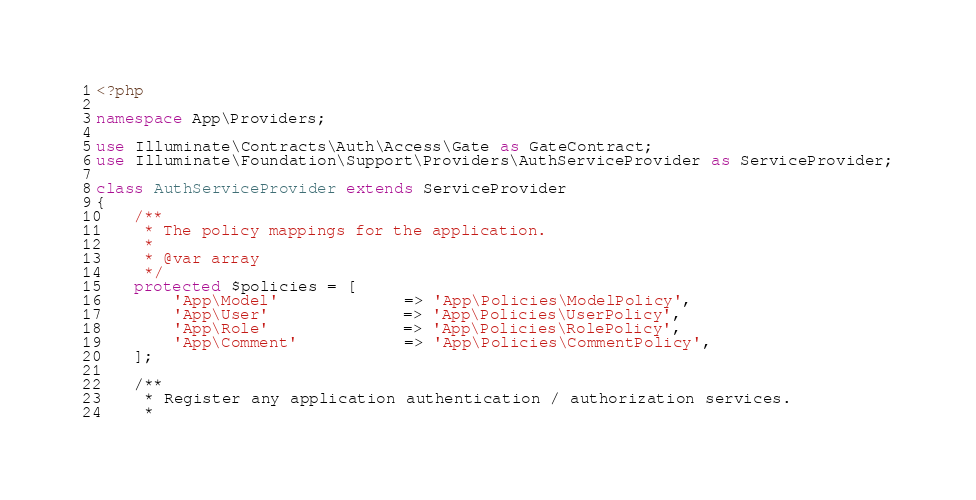Convert code to text. <code><loc_0><loc_0><loc_500><loc_500><_PHP_><?php

namespace App\Providers;

use Illuminate\Contracts\Auth\Access\Gate as GateContract;
use Illuminate\Foundation\Support\Providers\AuthServiceProvider as ServiceProvider;

class AuthServiceProvider extends ServiceProvider
{
    /**
     * The policy mappings for the application.
     *
     * @var array
     */
    protected $policies = [
        'App\Model'             => 'App\Policies\ModelPolicy',
        'App\User'              => 'App\Policies\UserPolicy',
        'App\Role'              => 'App\Policies\RolePolicy',
        'App\Comment'           => 'App\Policies\CommentPolicy',
    ];

    /**
     * Register any application authentication / authorization services.
     *</code> 